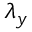<formula> <loc_0><loc_0><loc_500><loc_500>{ \lambda } _ { y }</formula> 